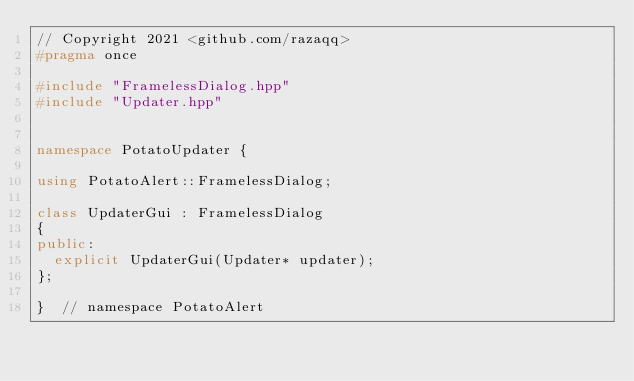<code> <loc_0><loc_0><loc_500><loc_500><_C++_>// Copyright 2021 <github.com/razaqq>
#pragma once

#include "FramelessDialog.hpp"
#include "Updater.hpp"


namespace PotatoUpdater {

using PotatoAlert::FramelessDialog;

class UpdaterGui : FramelessDialog
{
public:
	explicit UpdaterGui(Updater* updater);
};

}  // namespace PotatoAlert
</code> 